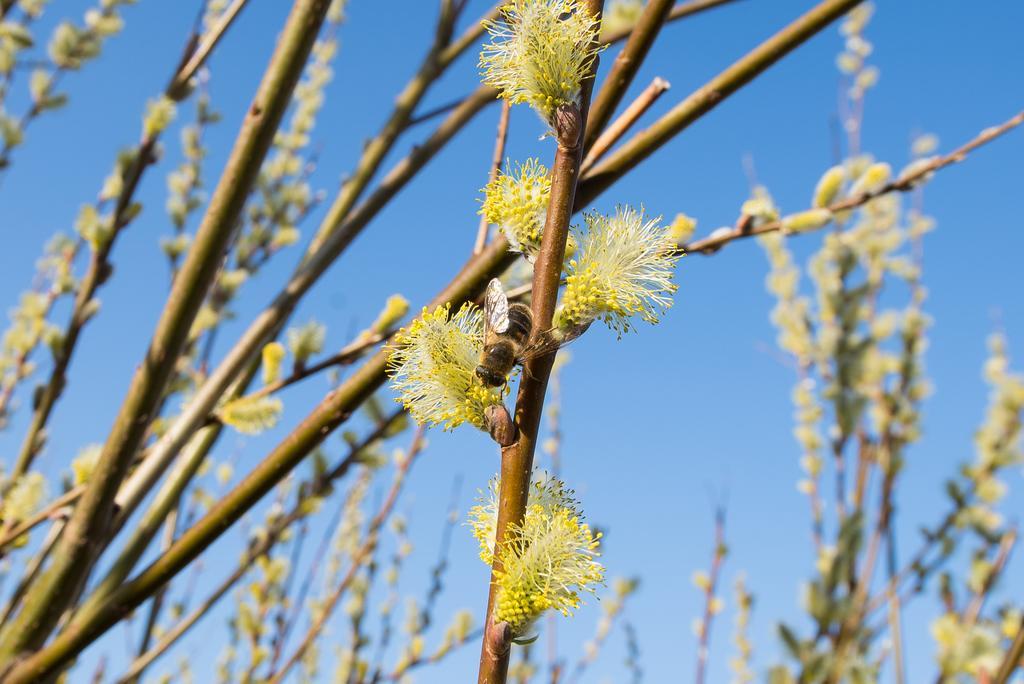Describe this image in one or two sentences. In this image there are few plants having flowers. Front side of image there is a stem having few flowers and an insect on it. Background there is sky. 